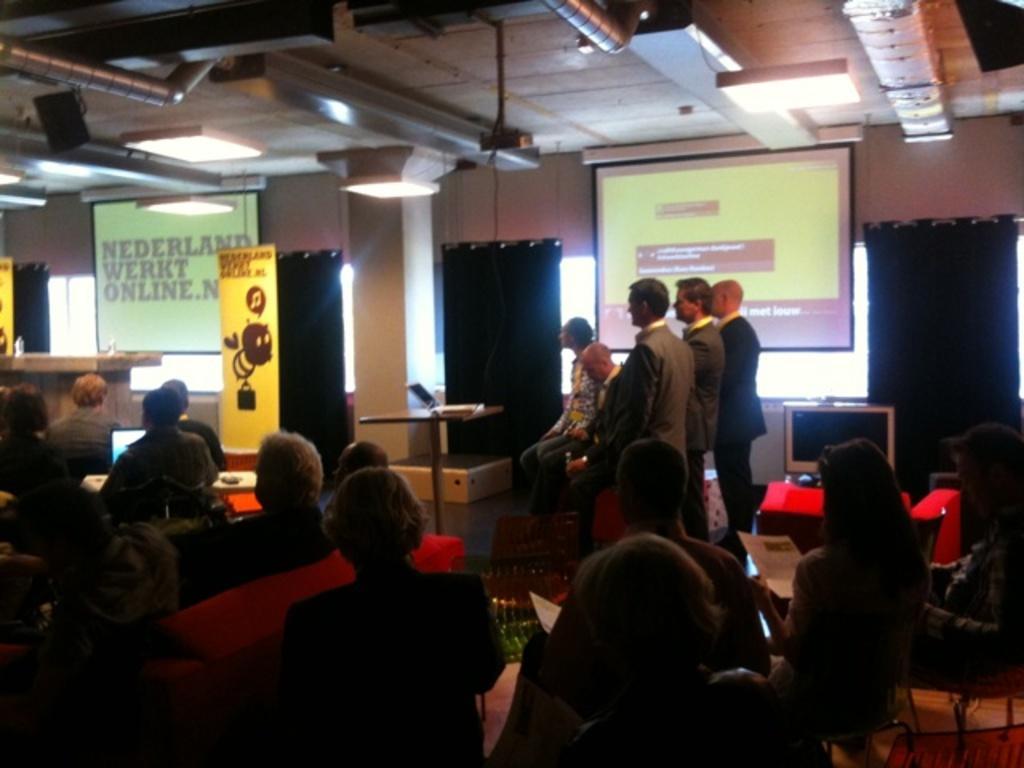Describe this image in one or two sentences. In the center of the image we can see a few people are standing and a few people are sitting on the chairs. And we can see they are in different costumes. Among them, we can see a few people are holding some objects. In the background, there is a wall, pillar, screens with some text, curtains, lights and a few other objects. 